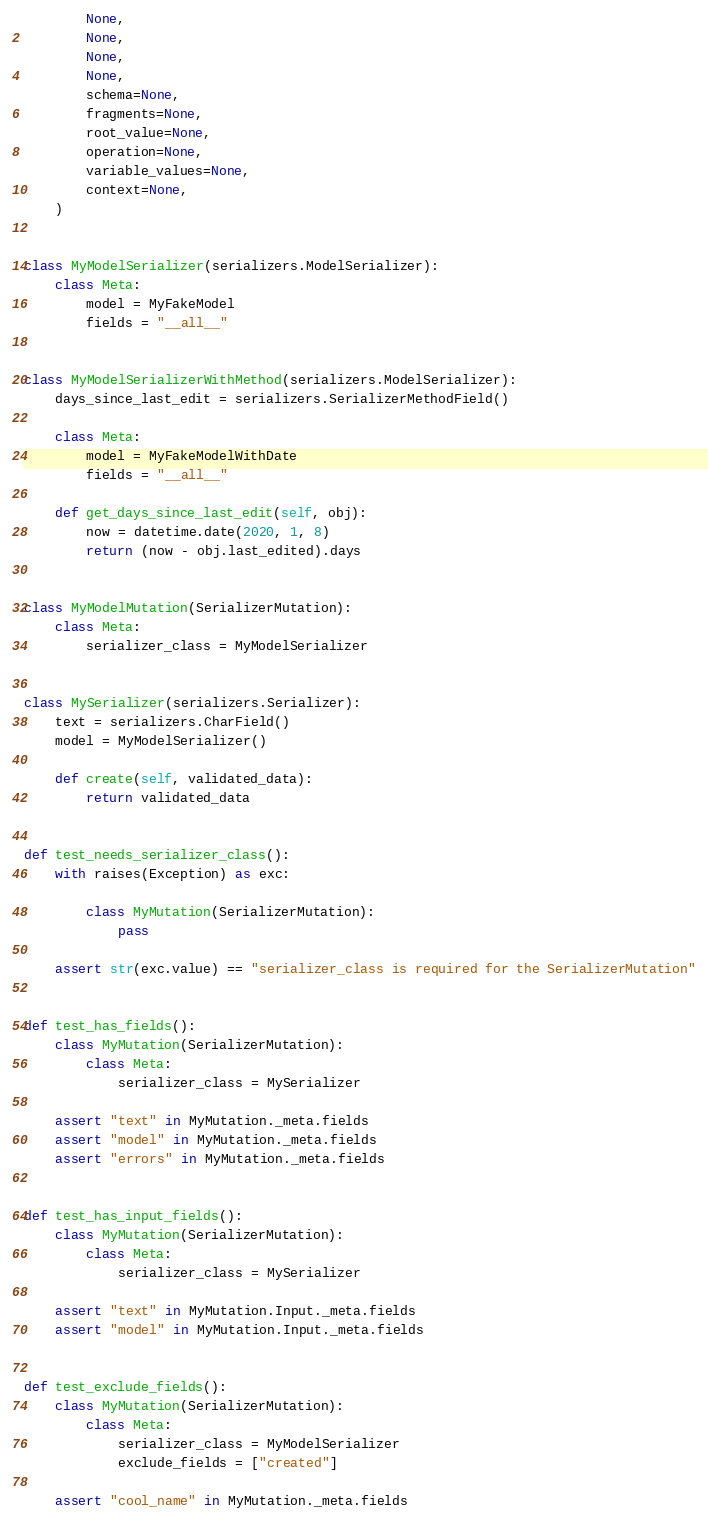Convert code to text. <code><loc_0><loc_0><loc_500><loc_500><_Python_>        None,
        None,
        None,
        None,
        schema=None,
        fragments=None,
        root_value=None,
        operation=None,
        variable_values=None,
        context=None,
    )


class MyModelSerializer(serializers.ModelSerializer):
    class Meta:
        model = MyFakeModel
        fields = "__all__"


class MyModelSerializerWithMethod(serializers.ModelSerializer):
    days_since_last_edit = serializers.SerializerMethodField()

    class Meta:
        model = MyFakeModelWithDate
        fields = "__all__"

    def get_days_since_last_edit(self, obj):
        now = datetime.date(2020, 1, 8)
        return (now - obj.last_edited).days


class MyModelMutation(SerializerMutation):
    class Meta:
        serializer_class = MyModelSerializer


class MySerializer(serializers.Serializer):
    text = serializers.CharField()
    model = MyModelSerializer()

    def create(self, validated_data):
        return validated_data


def test_needs_serializer_class():
    with raises(Exception) as exc:

        class MyMutation(SerializerMutation):
            pass

    assert str(exc.value) == "serializer_class is required for the SerializerMutation"


def test_has_fields():
    class MyMutation(SerializerMutation):
        class Meta:
            serializer_class = MySerializer

    assert "text" in MyMutation._meta.fields
    assert "model" in MyMutation._meta.fields
    assert "errors" in MyMutation._meta.fields


def test_has_input_fields():
    class MyMutation(SerializerMutation):
        class Meta:
            serializer_class = MySerializer

    assert "text" in MyMutation.Input._meta.fields
    assert "model" in MyMutation.Input._meta.fields


def test_exclude_fields():
    class MyMutation(SerializerMutation):
        class Meta:
            serializer_class = MyModelSerializer
            exclude_fields = ["created"]

    assert "cool_name" in MyMutation._meta.fields</code> 